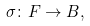<formula> <loc_0><loc_0><loc_500><loc_500>\sigma \colon F \to B ,</formula> 